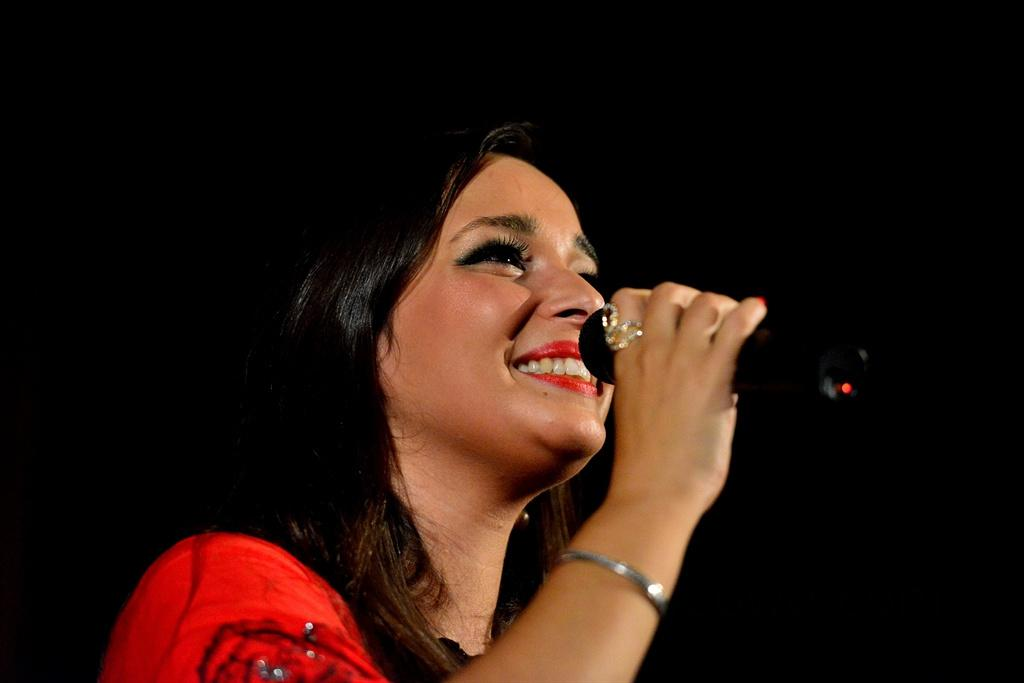What is the main subject of the image? The main subject of the image is a woman. What is the woman wearing in the image? The woman is wearing a red top. What expression does the woman have in the image? The woman is smiling. What object is the woman holding in the image? The woman is holding a mic. Can you see a kitty playing with a visitor in the image? There is no kitty or visitor present in the image. Is there a knot tied in the woman's hair in the image? There is no mention of the woman's hair in the provided facts, so it cannot be determined if there is a knot tied in it. 